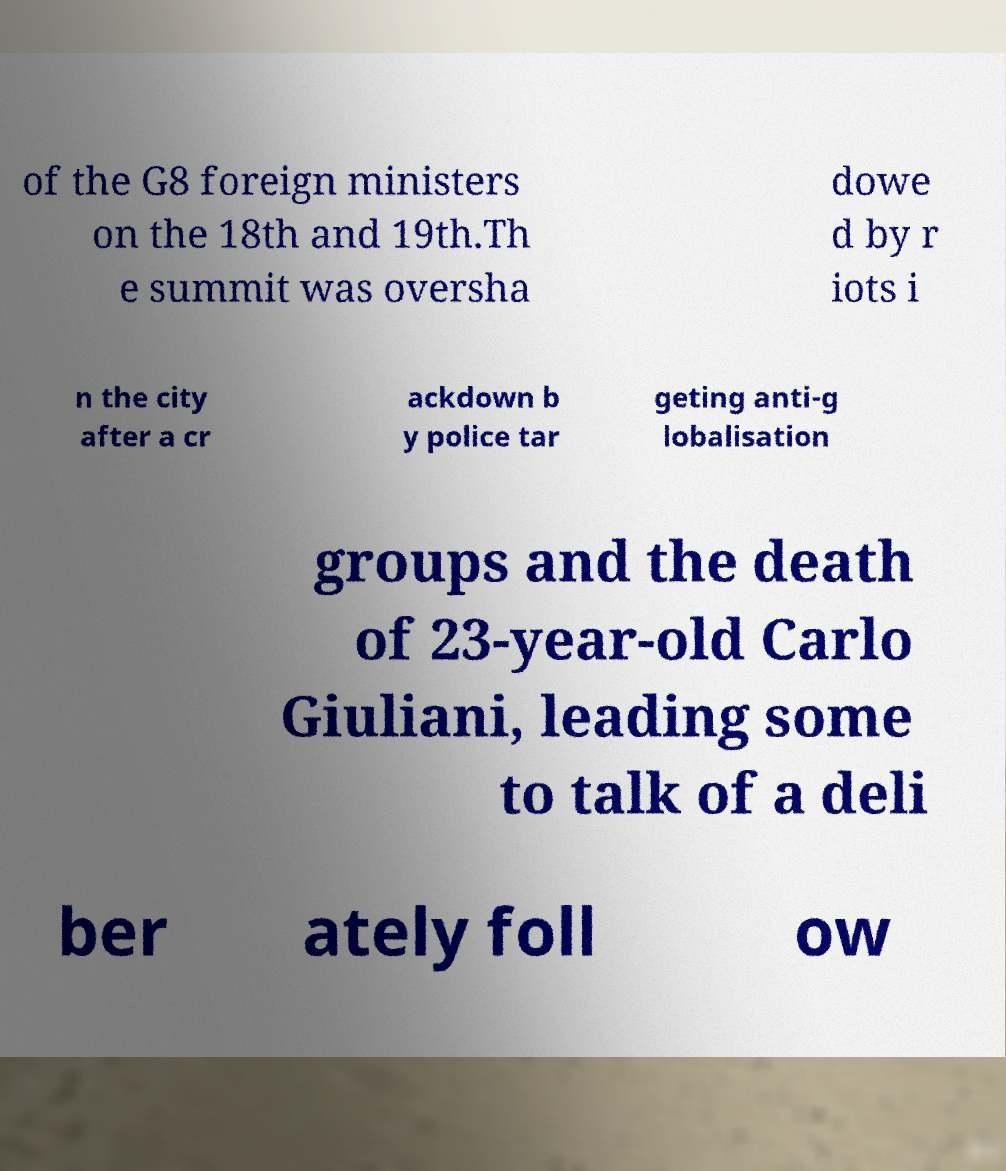Please identify and transcribe the text found in this image. of the G8 foreign ministers on the 18th and 19th.Th e summit was oversha dowe d by r iots i n the city after a cr ackdown b y police tar geting anti-g lobalisation groups and the death of 23-year-old Carlo Giuliani, leading some to talk of a deli ber ately foll ow 